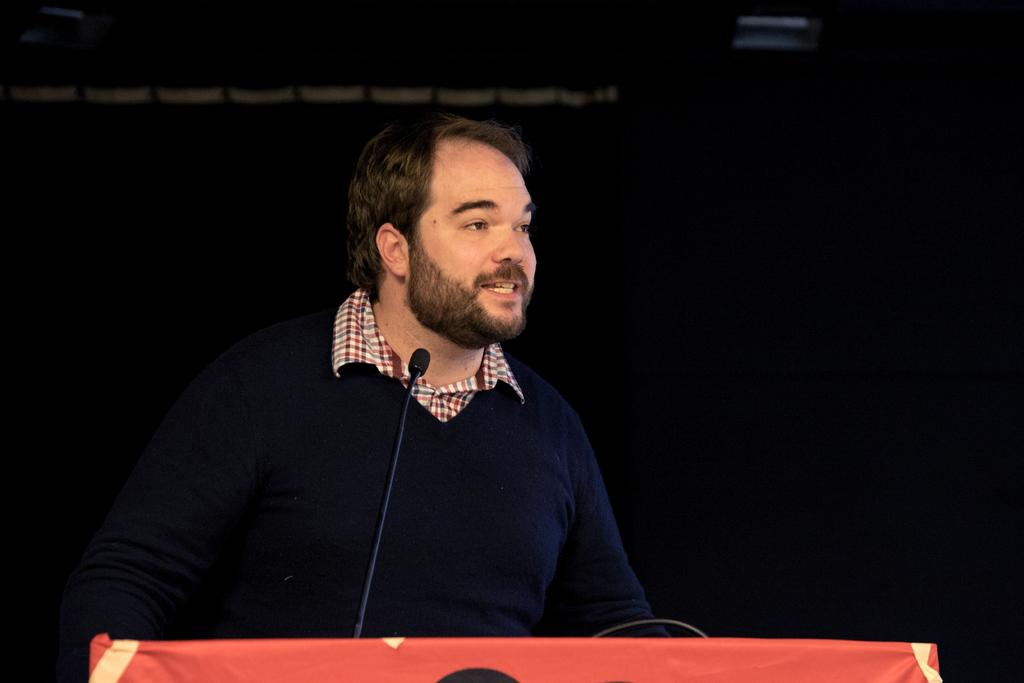What is the main subject of the image? There is a man standing in the image. What is the man doing in the image? The man is speaking. What object is on the table in the image? A microphone is present on the table. How would you describe the background of the image? The backdrop is dark. Can you see a pickle on the table next to the microphone? No, there is no pickle present in the image. Is the man's grandmother standing next to him in the image? There is no mention of a grandmother in the image, and only the man is visible. 